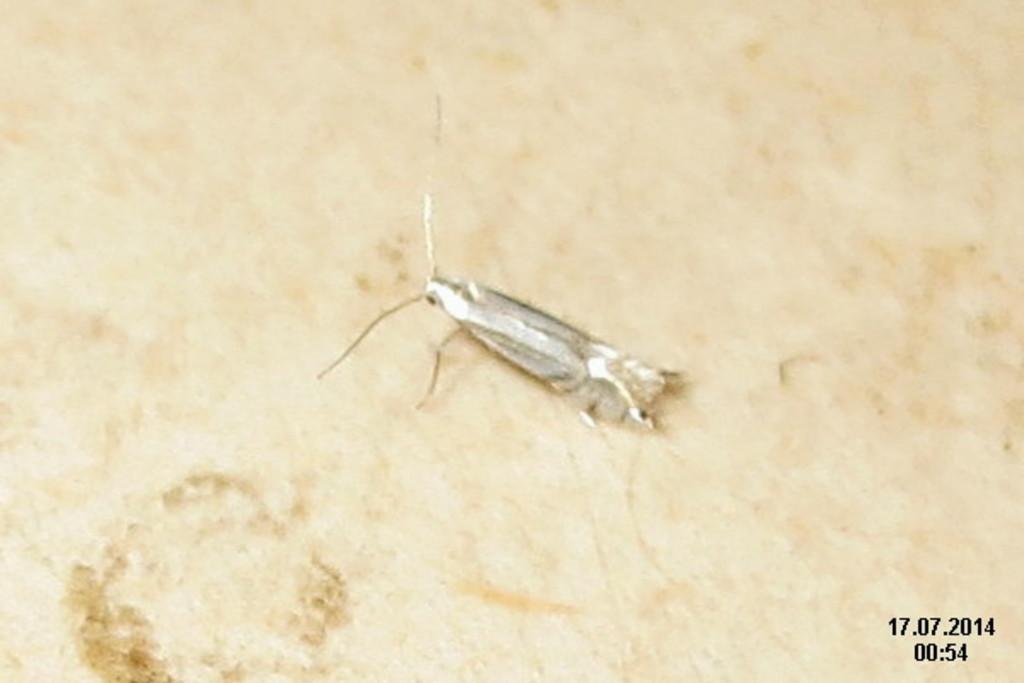How would you summarize this image in a sentence or two? In this picture we can see an insect on the surface and in the bottom right we can see some numbers. 